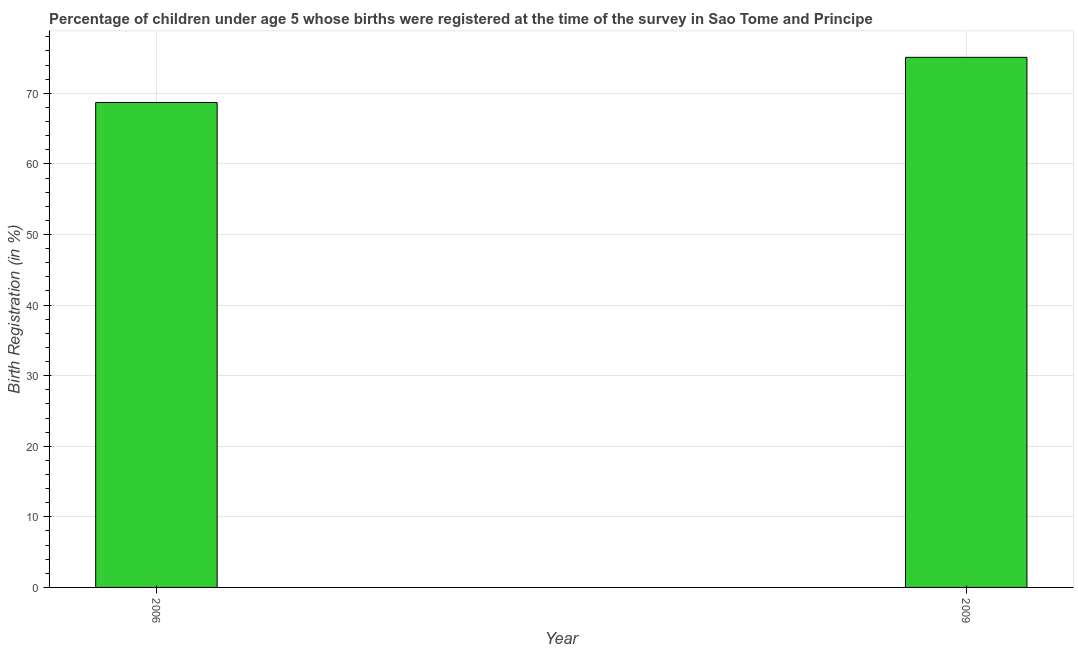What is the title of the graph?
Offer a terse response. Percentage of children under age 5 whose births were registered at the time of the survey in Sao Tome and Principe. What is the label or title of the X-axis?
Provide a short and direct response. Year. What is the label or title of the Y-axis?
Offer a terse response. Birth Registration (in %). What is the birth registration in 2009?
Your answer should be very brief. 75.1. Across all years, what is the maximum birth registration?
Ensure brevity in your answer.  75.1. Across all years, what is the minimum birth registration?
Give a very brief answer. 68.7. In which year was the birth registration minimum?
Your response must be concise. 2006. What is the sum of the birth registration?
Offer a very short reply. 143.8. What is the average birth registration per year?
Offer a very short reply. 71.9. What is the median birth registration?
Offer a terse response. 71.9. Do a majority of the years between 2009 and 2006 (inclusive) have birth registration greater than 42 %?
Your answer should be compact. No. What is the ratio of the birth registration in 2006 to that in 2009?
Offer a terse response. 0.92. Is the birth registration in 2006 less than that in 2009?
Keep it short and to the point. Yes. In how many years, is the birth registration greater than the average birth registration taken over all years?
Provide a succinct answer. 1. How many years are there in the graph?
Provide a succinct answer. 2. What is the Birth Registration (in %) of 2006?
Your response must be concise. 68.7. What is the Birth Registration (in %) of 2009?
Your answer should be very brief. 75.1. What is the ratio of the Birth Registration (in %) in 2006 to that in 2009?
Offer a terse response. 0.92. 